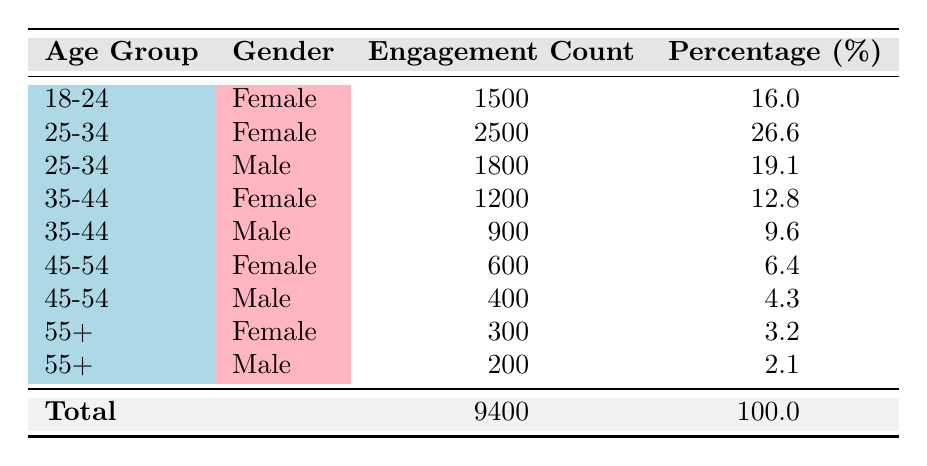What is the total engagement count for all followers? To find the total engagement count, we need to sum the engagement counts of all age groups and genders listed in the table: 1500 + 2500 + 1800 + 1200 + 900 + 600 + 400 + 300 + 200 = 9400.
Answer: 9400 Which age group has the highest engagement count? The age group with the highest engagement count can be found by comparing the engagement counts across all age groups: 1500 (18-24), 2500 (25-34), 1200 (35-44), 600 (45-54), and 300 (55+). The highest is 2500, which is for the age group 25-34.
Answer: 25-34 Is the engagement count for males in the 35-44 age group higher than that of females in the same age group? The engagement count for males aged 35-44 is 900, while for females in the same age group it is 1200. Since 900 is less than 1200, the statement is false.
Answer: No What percentage of followers are aged 45-54? To find the percentage for the 45-54 age group, we need to add the engagement counts for this group (600 for females and 400 for males), which is 1000. Then, we divide by the total engagement count (9400) and multiply by 100: (1000/9400) * 100 = 10.64%.
Answer: 10.64% How many more female followers engage with holistic wellness content than male followers in the age group 25-34? For the age group 25-34, the engagement count for females is 2500 and for males, it is 1800. To find the difference, we subtract the male count from the female count: 2500 - 1800 = 700.
Answer: 700 True or False: There are more followers in the 18-24 age group than in the 45-54 age group. The engagement count for the 18-24 age group is 1500 and for the 45-54 age group it is 1000 (600 for females and 400 for males). Since 1500 is greater than 1000, the statement is true.
Answer: True What is the engagement count for male followers aged 55 and above combined? The engagement count for males aged 55+ is 200. Thus, to find the combined engagement count for males aged 55 and above, we only sum this single row as there are no additional age groups above 55 listed: 200.
Answer: 200 Which gender has the lowest total engagement count across all age groups? First, we sum the engagement counts for males: 1800 (25-34) + 900 (35-44) + 400 (45-54) + 200 (55+) = 3300. Then for females: 1500 (18-24) + 2500 (25-34) + 1200 (35-44) + 600 (45-54) + 300 (55+) = 5600. Since 3300 (males) is less than 5600 (females), males have the lowest total engagement count.
Answer: Males 